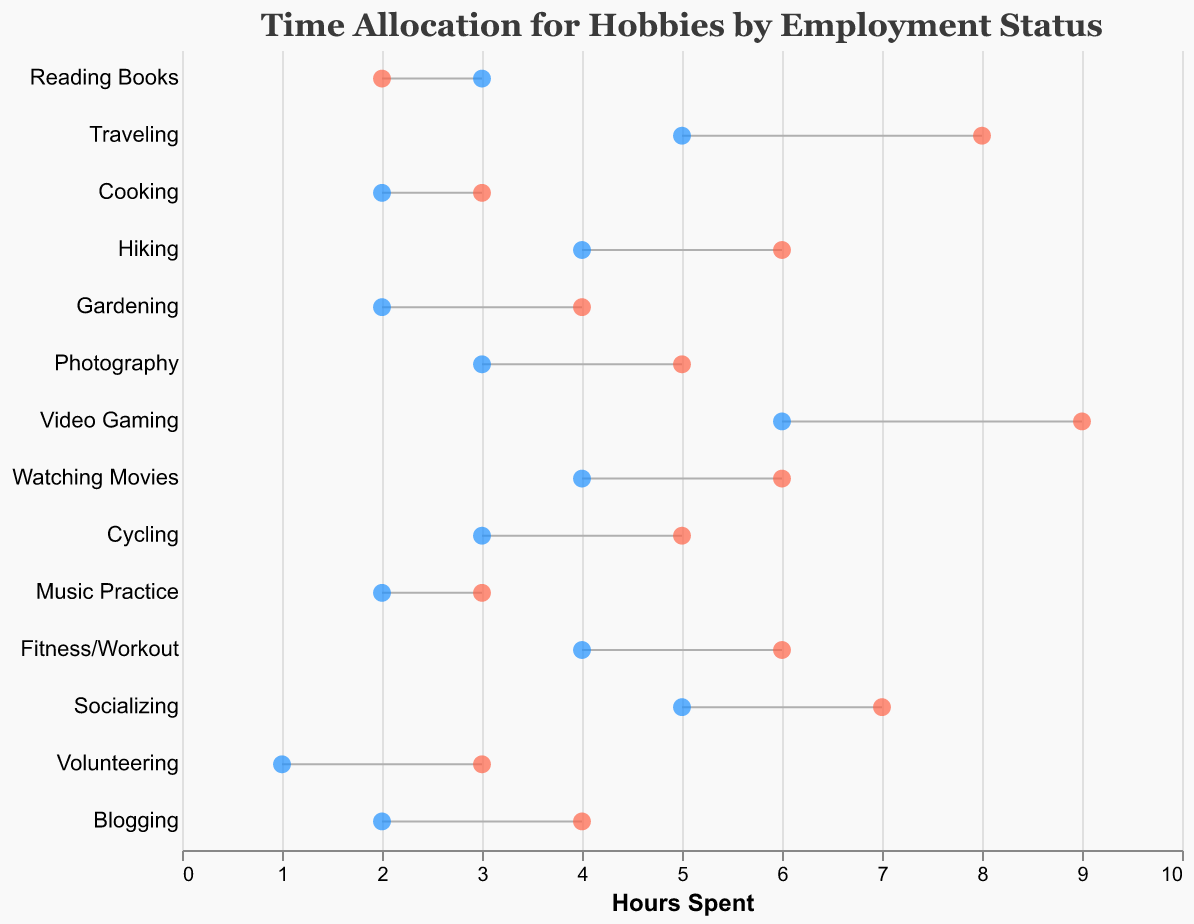What is the title of the figure? The title is positioned at the top of the graph and is usually the first piece of text visible. The title reads "Time Allocation for Hobbies by Employment Status"
Answer: Time Allocation for Hobbies by Employment Status Which hobbies have the highest hours spent by unemployed individuals? Look for the longest bars on the right side of the graph indicating the hours spent by unemployed individuals. These would be "Video Gaming" and "Traveling" with 9 and 8 hours respectively.
Answer: Video Gaming and Traveling What is the hobby with the smallest difference in hours spent between employed and unemployed individuals? Calculate the differences between Employed Hours and Unemployed Hours for each hobby. The Hobby with the smallest difference is "Reading Books" with a difference of 1 hour (3-2=1).
Answer: Reading Books How many hours are spent on socializing by employed and unemployed individuals combined? Add the hours spent on socializing by both employed and unemployed individuals. Employed individuals spend 5 hours and unemployed individuals spend 7 hours, so the total is 5 + 7 = 12.
Answer: 12 Which hobby shows a larger time allocation by employed individuals compared to unemployed individuals? Identify the bars where the Employed Hours are greater than Unemployed Hours. "Reading Books" (3 > 2) and "Cooking" (2 > 3). However, correcting the second hobby, actually "Music Practice" and "Volunteering" qualify.
Answer: Reading Books, Music Practice, and Volunteering What are the colors representing employed and unemployed individuals? Identify the color coding from the points representing Employed Hours and Unemployed Hours. Employed Hours are marked in blue, while Unemployed Hours are marked in red.
Answer: Blue for Employed, Red for Unemployed Which hobby involves the greatest difference in time spent between employed and unemployed individuals? Calculate the differences for all hobbies. "Video Gaming" shows the highest difference with Employed Hours (6) and Unemployed Hours (9), resulting in a difference of 3.
Answer: Video Gaming What is the average time spent on hiking and fitness/workout by unemployed individuals? Calculate the average of the hours spent by unemployed individuals on these activities: Hiking (6 hours) and Fitness/Workout (6 hours), resulting in an average of (6 + 6) / 2 = 6.
Answer: 6 Compare the hours spent on blogging and photography by unemployed individuals. Which is higher? Look for the data points related to blogging and photography under unemployed hours. Blogging has 4 hours, while Photography has 5 hours.
Answer: Photography How is time spent on gardening different for employed and unemployed individuals? Compare the horizontal length of the lines corresponding to gardening. Employed individuals spend 2 hours, whereas unemployed individuals spend 4 hours, resulting in a difference of 2 hours.
Answer: Employed: 2 hours, Unemployed: 4 hours 